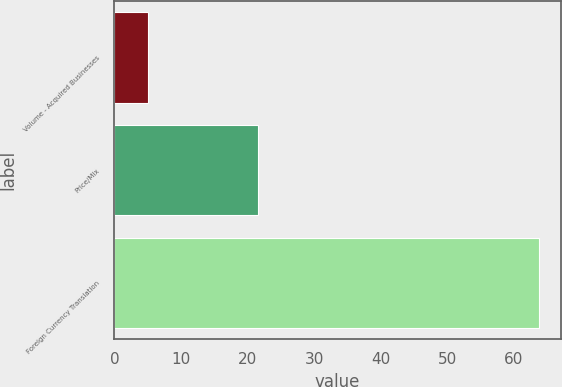Convert chart. <chart><loc_0><loc_0><loc_500><loc_500><bar_chart><fcel>Volume - Acquired Businesses<fcel>Price/Mix<fcel>Foreign Currency Translation<nl><fcel>5<fcel>21.5<fcel>63.8<nl></chart> 